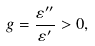<formula> <loc_0><loc_0><loc_500><loc_500>g = \frac { \varepsilon ^ { \prime \prime } } { \varepsilon ^ { \prime } } > 0 ,</formula> 